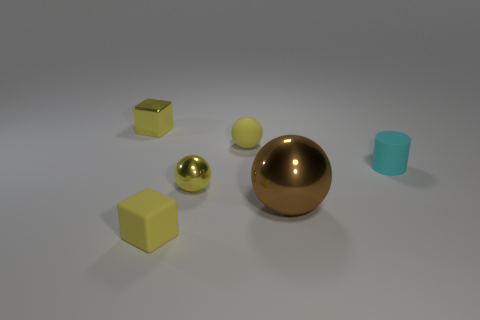Subtract all yellow cubes. How many were subtracted if there are1yellow cubes left? 1 Add 3 small matte balls. How many objects exist? 9 Subtract all cylinders. How many objects are left? 5 Add 6 small cyan rubber things. How many small cyan rubber things are left? 7 Add 2 big green rubber blocks. How many big green rubber blocks exist? 2 Subtract 0 green blocks. How many objects are left? 6 Subtract all small green metallic spheres. Subtract all yellow metallic balls. How many objects are left? 5 